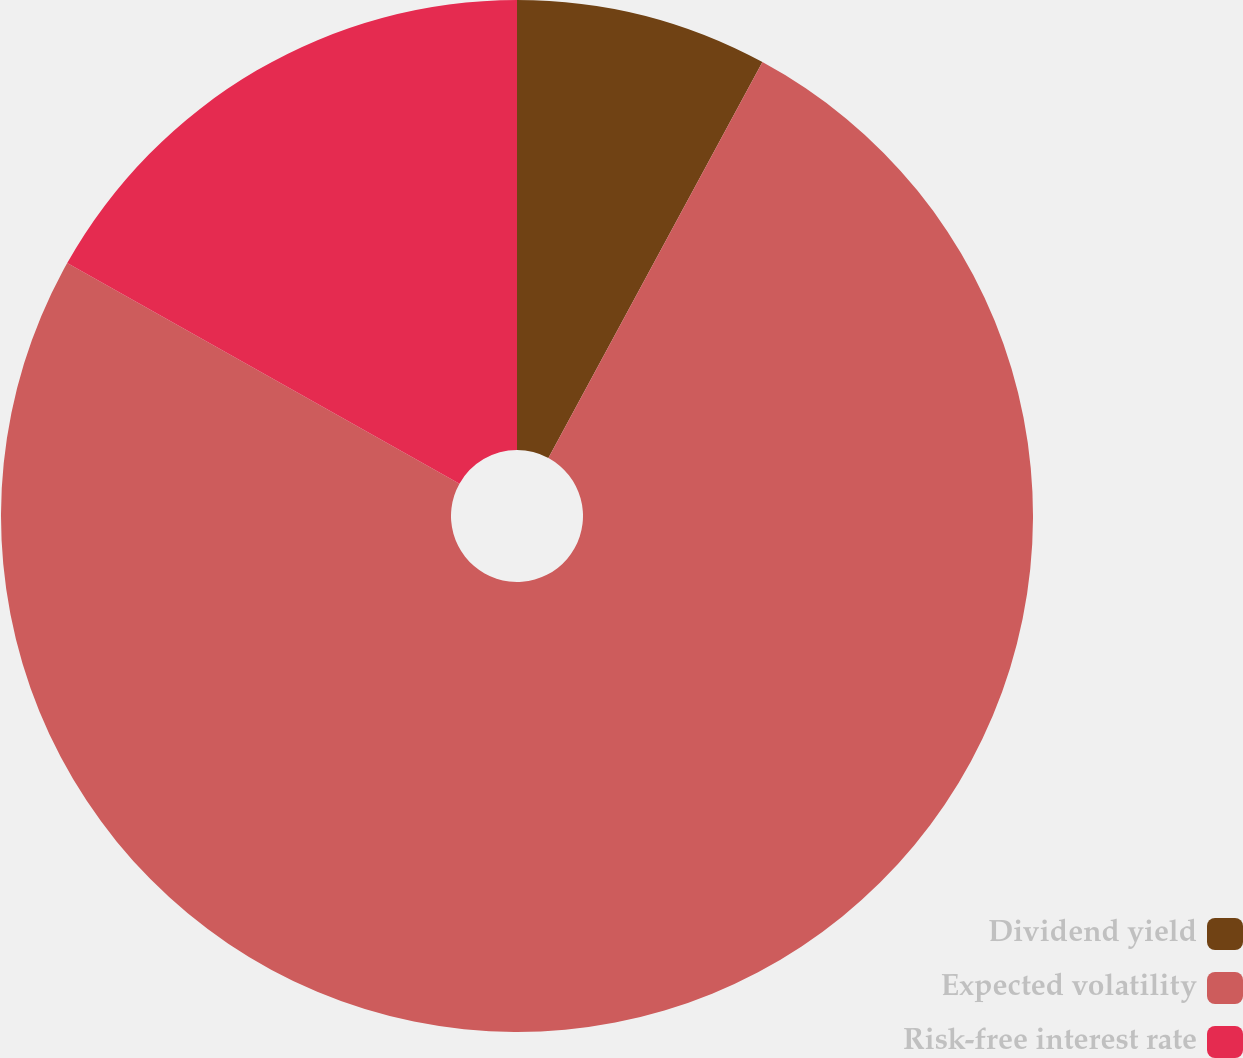<chart> <loc_0><loc_0><loc_500><loc_500><pie_chart><fcel>Dividend yield<fcel>Expected volatility<fcel>Risk-free interest rate<nl><fcel>7.89%<fcel>75.27%<fcel>16.85%<nl></chart> 